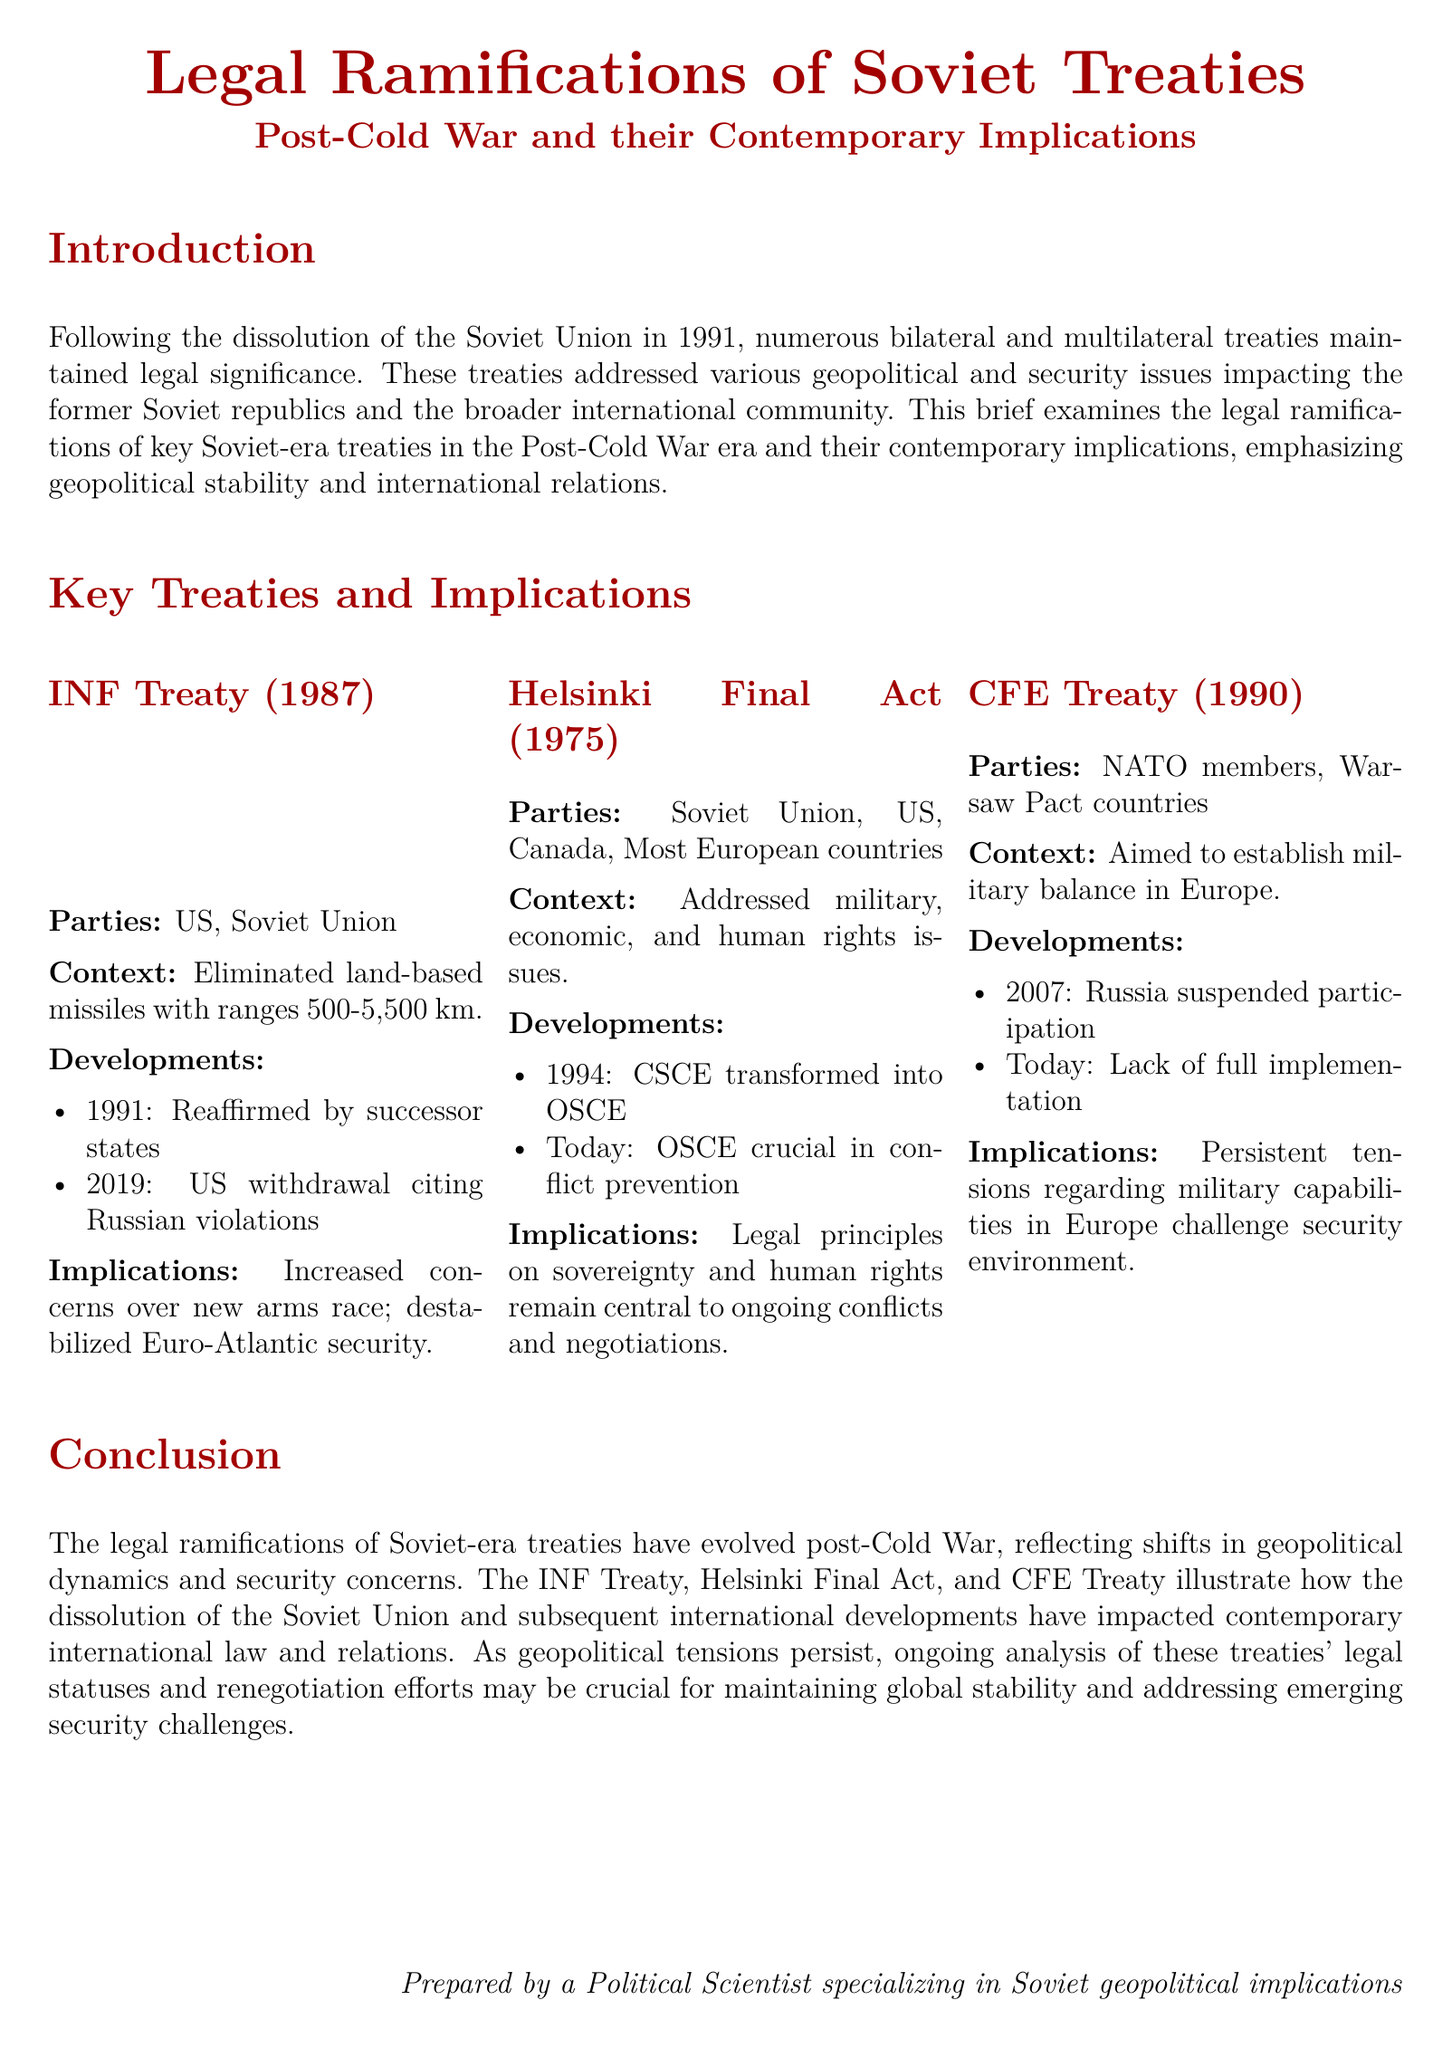What treaty eliminated land-based missiles? The treaty that eliminated land-based missiles is the INF Treaty.
Answer: INF Treaty Who were the parties involved in the Helsinki Final Act? The parties involved in the Helsinki Final Act were the Soviet Union, US, Canada, and most European countries.
Answer: Soviet Union, US, Canada, Most European countries What year was the CFE Treaty signed? The CFE Treaty was signed in 1990.
Answer: 1990 What significant change occurred to the CSCE in 1994? In 1994, the CSCE was transformed into the OSCE.
Answer: Transformed into OSCE What action did Russia take regarding the CFE Treaty in 2007? Russia suspended its participation in the CFE Treaty in 2007.
Answer: Suspended participation What are the contemporary implications of the Helsinki Final Act? The contemporary implications involve legal principles on sovereignty and human rights.
Answer: Sovereignty and human rights How did the INF Treaty impact Euro-Atlantic security? The INF Treaty increased concerns over a new arms race and destabilized Euro-Atlantic security.
Answer: Destabilized Euro-Atlantic security What is the primary focus of the legal ramifications discussed in the conclusion? The primary focus is on the evolution reflecting shifts in geopolitical dynamics and security concerns.
Answer: Geopolitical dynamics and security concerns 